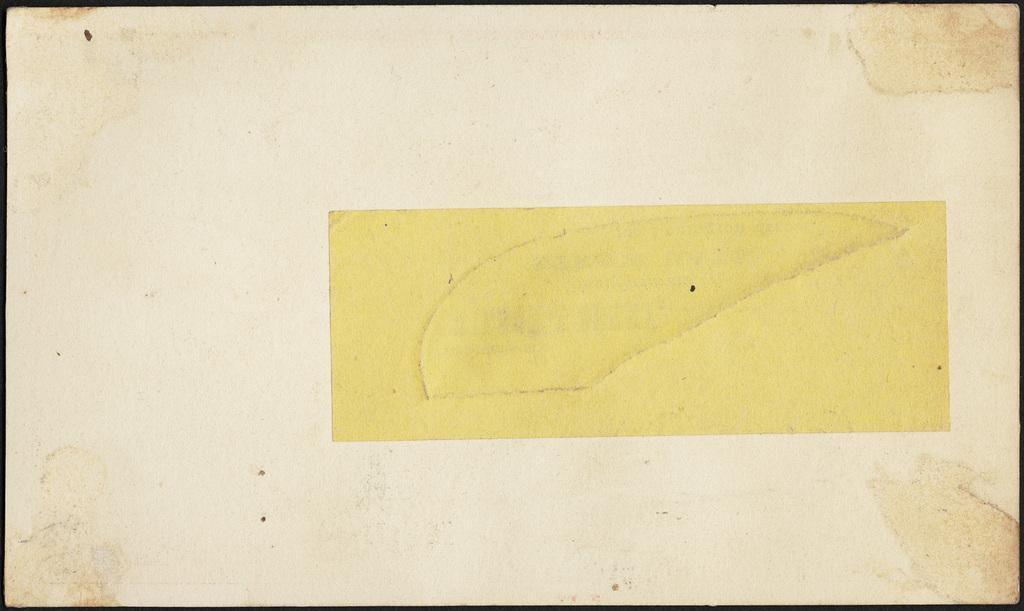How would you summarize this image in a sentence or two? In this image we can see paper with borders. 